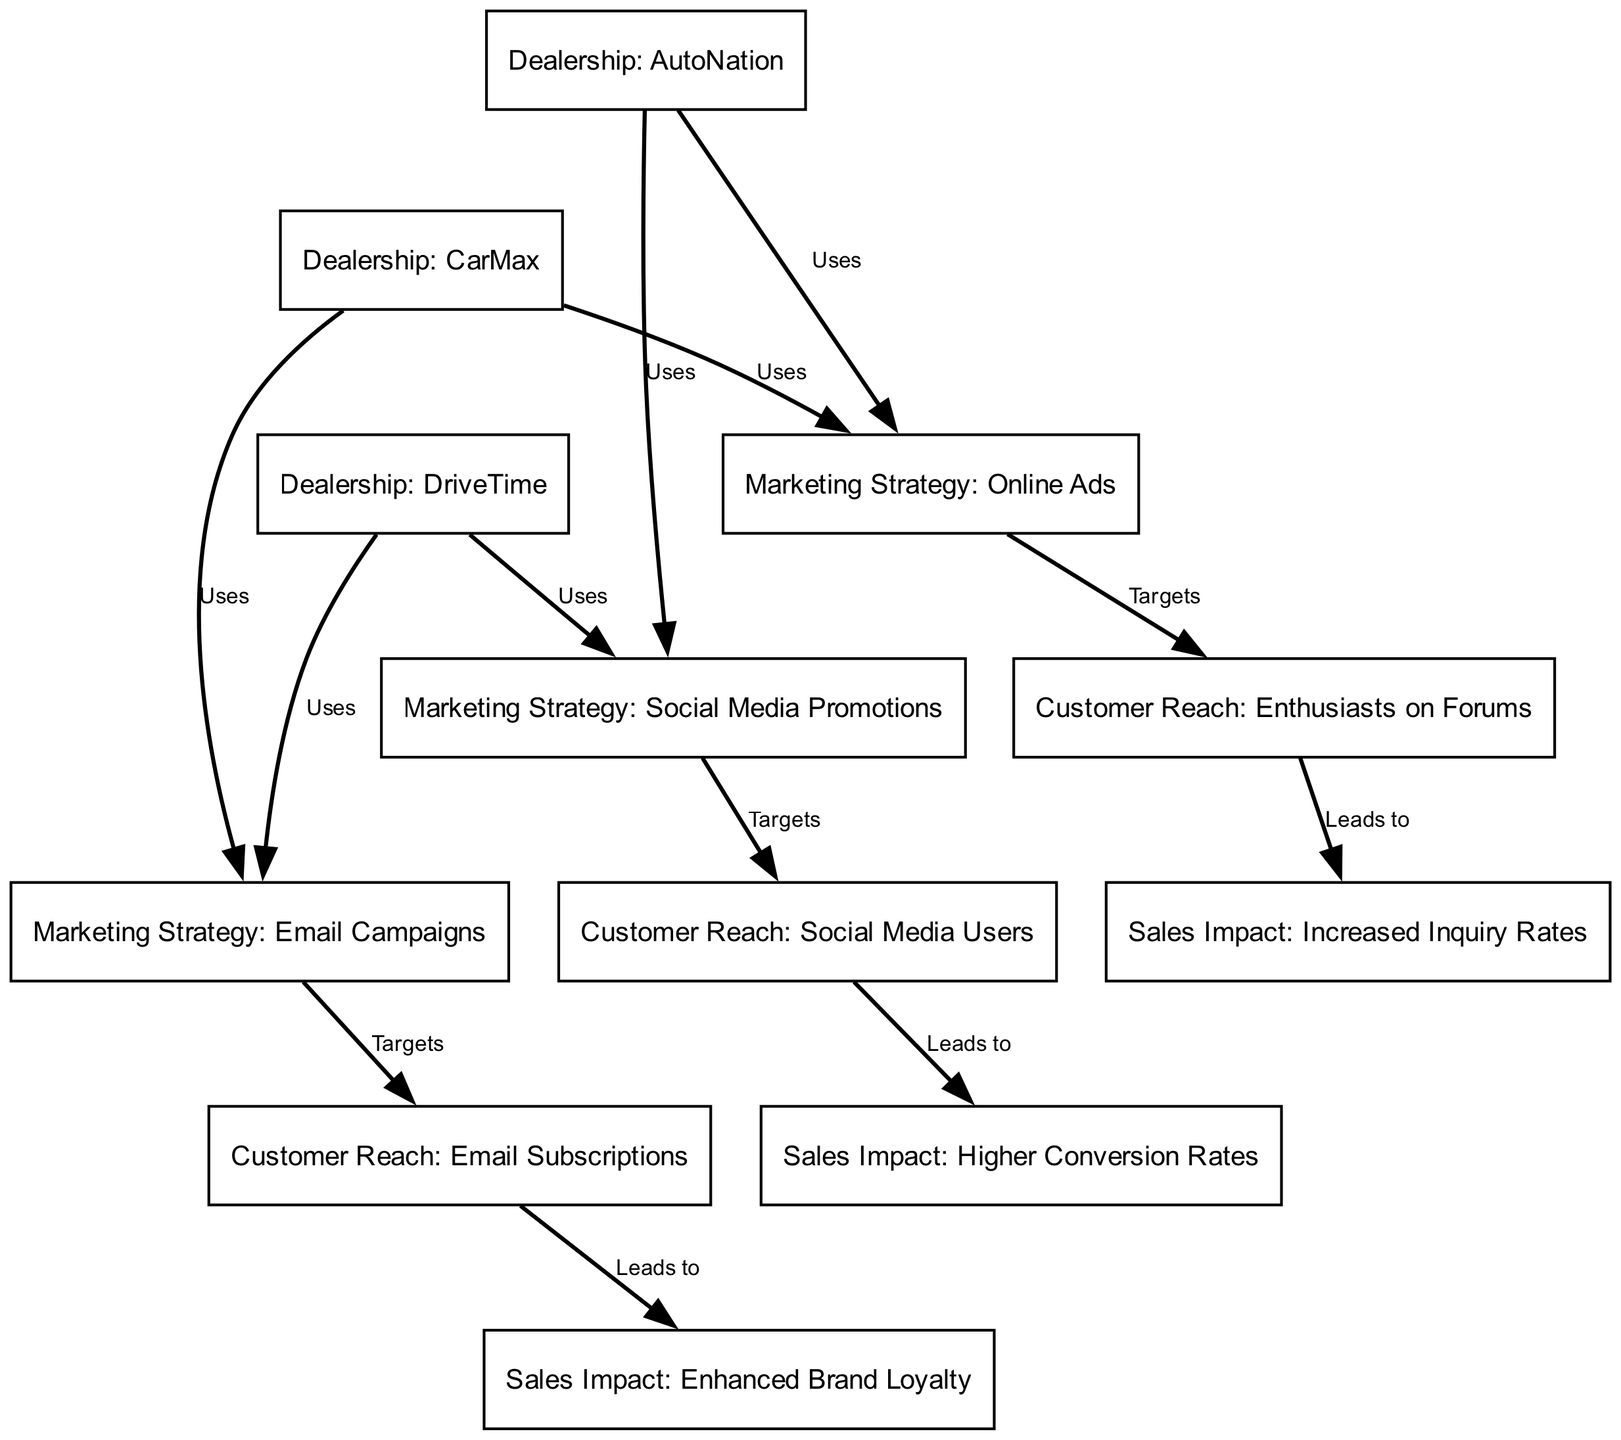What are the three dealerships mentioned in the diagram? The diagram lists three dealerships: AutoNation, CarMax, and DriveTime. These are represented as nodes in the visual representation.
Answer: AutoNation, CarMax, DriveTime Which marketing strategy is used by AutoNation? According to the diagram, AutoNation uses Online Ads and Social Media Promotions. These relationships are depicted as edges connecting the dealership to its marketing strategies.
Answer: Online Ads, Social Media Promotions How many marketing strategies are shown in the diagram? The diagram contains three marketing strategies: Online Ads, Social Media Promotions, and Email Campaigns. This can be counted by identifying the relevant nodes.
Answer: 3 What is the sales impact associated with customer reach from Social Media Users? The diagram indicates that reaching Social Media Users leads to Higher Conversion Rates, which is noted as a direct outcome of targeting this customer group.
Answer: Higher Conversion Rates Which dealership uses Email Campaigns as a marketing strategy? The information in the diagram shows that CarMax uses Email Campaigns, indicated by the directed edge connecting CarMax to this marketing strategy node.
Answer: CarMax Which customer reach is linked to Enhanced Brand Loyalty? The diagram tells us that Email Subscriptions lead to Enhanced Brand Loyalty, illustrating the connection from customer reach through to sales impact.
Answer: Email Subscriptions What are the sales impacts resulting from Enthusiasts on Forums? The diagram clearly shows that Enthusiasts on Forums leads to Increased Inquiry Rates, establishing a direct relationship to the sales impact node.
Answer: Increased Inquiry Rates How many total nodes are represented in the diagram? By counting all individual nodes in the diagram, we establish that there are twelve nodes in total, representing dealerships, marketing strategies, customer reach, and sales impacts.
Answer: 12 Which marketing strategy targets Enthusiasts on Forums? According to the diagram, Online Ads is the marketing strategy that specifically targets Enthusiasts on Forums, as shown by the relationship depicted in the edges.
Answer: Online Ads 